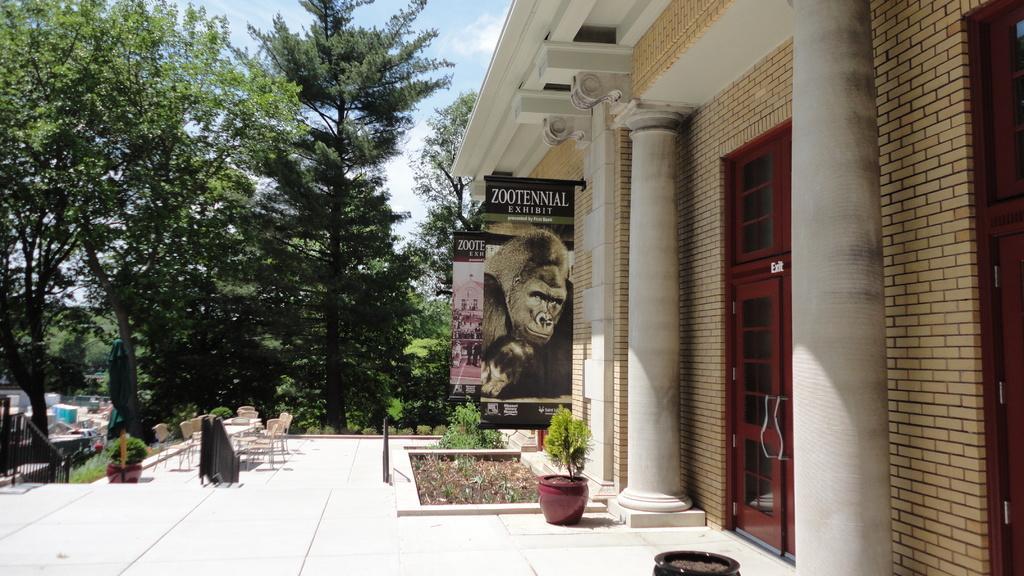Describe this image in one or two sentences. On the right side of the picture, we see a building, pillars and a door in brown color. Beside that, we see flower pots and plants. We see a black banner with text written on it. On the left side, we see a railing and the flower pot. We see plants and shrubs. There are tables and chairs. We see vehicles which are moving on the road. There are trees in the background. 